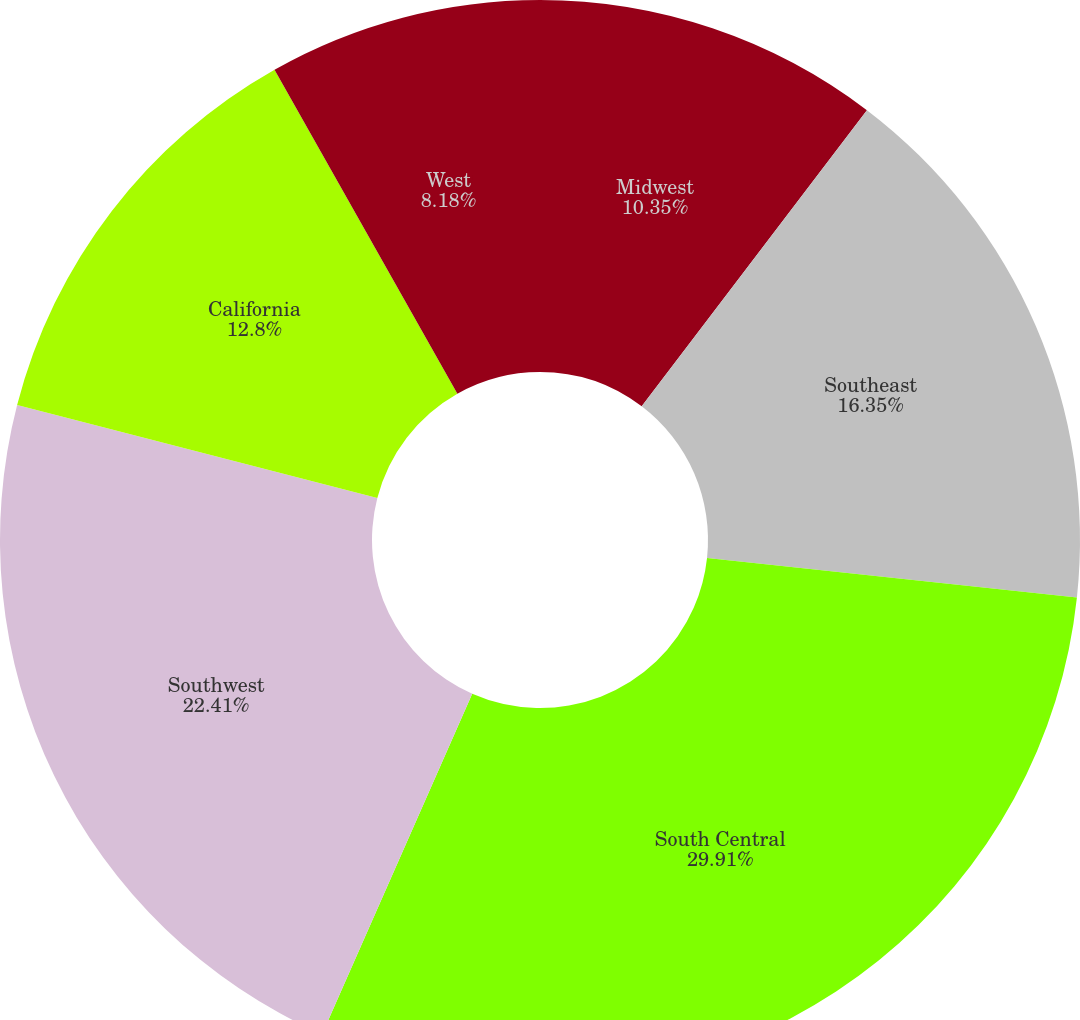Convert chart. <chart><loc_0><loc_0><loc_500><loc_500><pie_chart><fcel>Midwest<fcel>Southeast<fcel>South Central<fcel>Southwest<fcel>California<fcel>West<nl><fcel>10.35%<fcel>16.35%<fcel>29.91%<fcel>22.41%<fcel>12.8%<fcel>8.18%<nl></chart> 